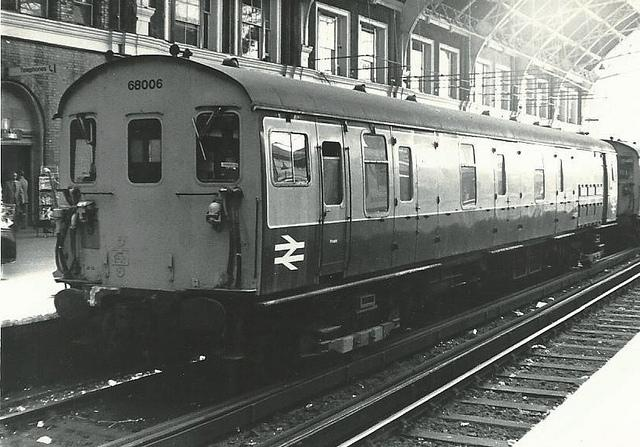What type of building is this? Please explain your reasoning. station. A train and tracks are inside the building. 